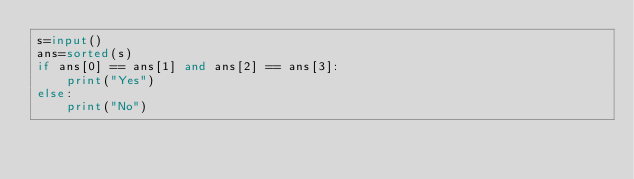Convert code to text. <code><loc_0><loc_0><loc_500><loc_500><_Python_>s=input()
ans=sorted(s)
if ans[0] == ans[1] and ans[2] == ans[3]:
    print("Yes")
else:
    print("No")</code> 